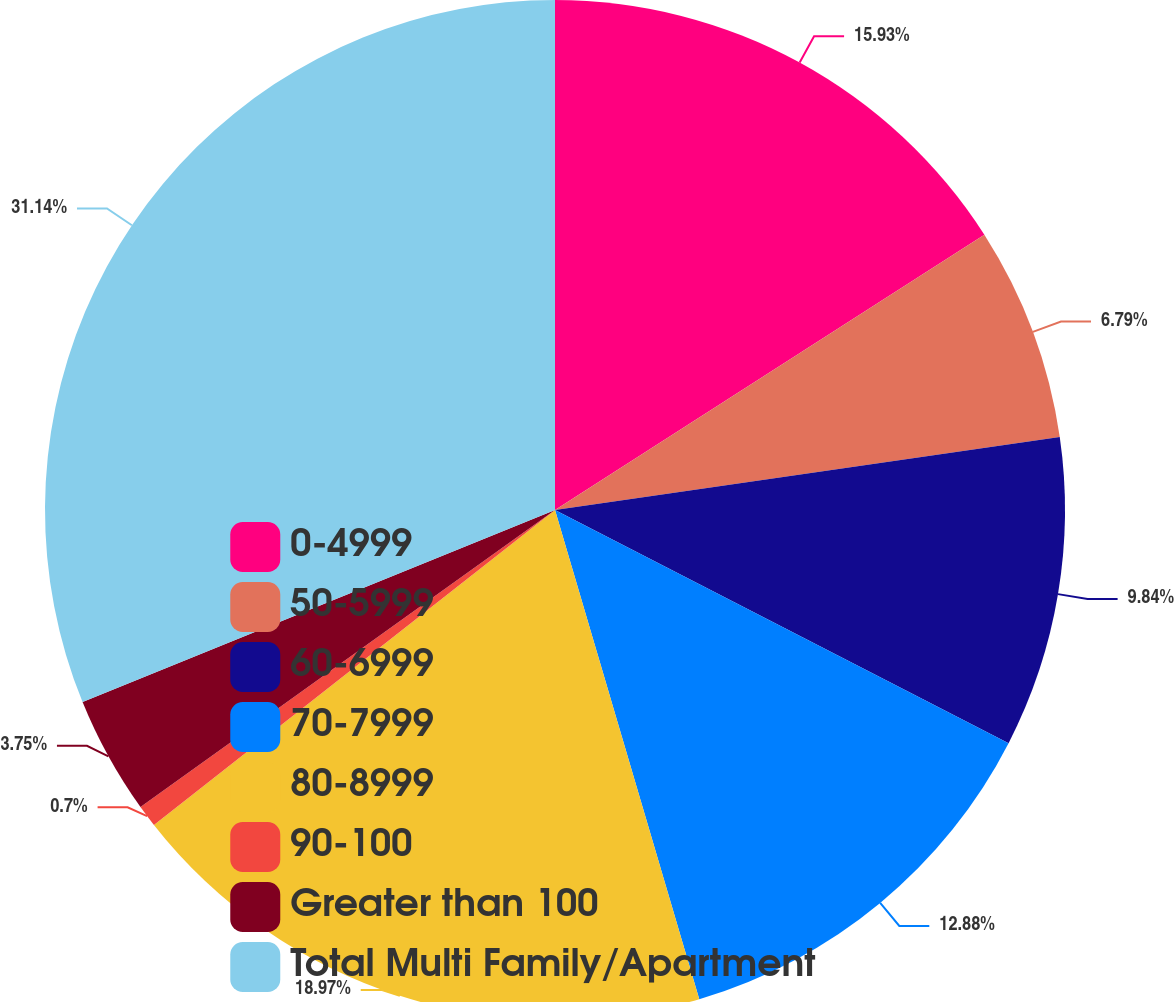Convert chart to OTSL. <chart><loc_0><loc_0><loc_500><loc_500><pie_chart><fcel>0-4999<fcel>50-5999<fcel>60-6999<fcel>70-7999<fcel>80-8999<fcel>90-100<fcel>Greater than 100<fcel>Total Multi Family/Apartment<nl><fcel>15.93%<fcel>6.79%<fcel>9.84%<fcel>12.88%<fcel>18.97%<fcel>0.7%<fcel>3.75%<fcel>31.15%<nl></chart> 